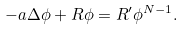<formula> <loc_0><loc_0><loc_500><loc_500>- a \Delta \phi + R \phi = R ^ { \prime } \phi ^ { N - 1 } .</formula> 